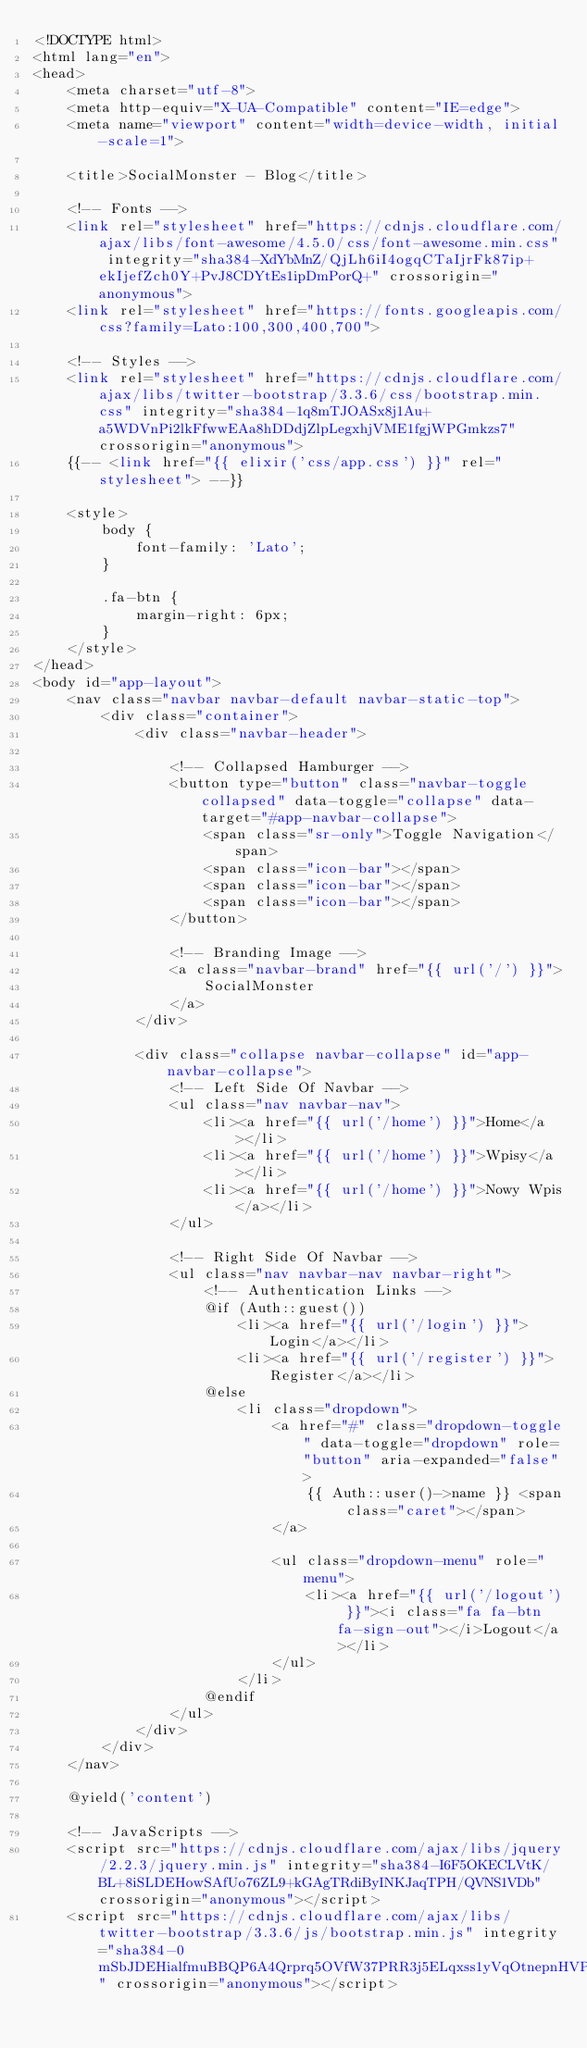Convert code to text. <code><loc_0><loc_0><loc_500><loc_500><_PHP_><!DOCTYPE html>
<html lang="en">
<head>
    <meta charset="utf-8">
    <meta http-equiv="X-UA-Compatible" content="IE=edge">
    <meta name="viewport" content="width=device-width, initial-scale=1">

    <title>SocialMonster - Blog</title>

    <!-- Fonts -->
    <link rel="stylesheet" href="https://cdnjs.cloudflare.com/ajax/libs/font-awesome/4.5.0/css/font-awesome.min.css" integrity="sha384-XdYbMnZ/QjLh6iI4ogqCTaIjrFk87ip+ekIjefZch0Y+PvJ8CDYtEs1ipDmPorQ+" crossorigin="anonymous">
    <link rel="stylesheet" href="https://fonts.googleapis.com/css?family=Lato:100,300,400,700">

    <!-- Styles -->
    <link rel="stylesheet" href="https://cdnjs.cloudflare.com/ajax/libs/twitter-bootstrap/3.3.6/css/bootstrap.min.css" integrity="sha384-1q8mTJOASx8j1Au+a5WDVnPi2lkFfwwEAa8hDDdjZlpLegxhjVME1fgjWPGmkzs7" crossorigin="anonymous">
    {{-- <link href="{{ elixir('css/app.css') }}" rel="stylesheet"> --}}

    <style>
        body {
            font-family: 'Lato';
        }

        .fa-btn {
            margin-right: 6px;
        }
    </style>
</head>
<body id="app-layout">
    <nav class="navbar navbar-default navbar-static-top">
        <div class="container">
            <div class="navbar-header">

                <!-- Collapsed Hamburger -->
                <button type="button" class="navbar-toggle collapsed" data-toggle="collapse" data-target="#app-navbar-collapse">
                    <span class="sr-only">Toggle Navigation</span>
                    <span class="icon-bar"></span>
                    <span class="icon-bar"></span>
                    <span class="icon-bar"></span>
                </button>

                <!-- Branding Image -->
                <a class="navbar-brand" href="{{ url('/') }}">
                    SocialMonster
                </a>
            </div>

            <div class="collapse navbar-collapse" id="app-navbar-collapse">
                <!-- Left Side Of Navbar -->
                <ul class="nav navbar-nav">
                    <li><a href="{{ url('/home') }}">Home</a></li>
                    <li><a href="{{ url('/home') }}">Wpisy</a></li>
                    <li><a href="{{ url('/home') }}">Nowy Wpis</a></li>
                </ul>

                <!-- Right Side Of Navbar -->
                <ul class="nav navbar-nav navbar-right">
                    <!-- Authentication Links -->
                    @if (Auth::guest())
                        <li><a href="{{ url('/login') }}">Login</a></li>
                        <li><a href="{{ url('/register') }}">Register</a></li>
                    @else
                        <li class="dropdown">
                            <a href="#" class="dropdown-toggle" data-toggle="dropdown" role="button" aria-expanded="false">
                                {{ Auth::user()->name }} <span class="caret"></span>
                            </a>

                            <ul class="dropdown-menu" role="menu">
                                <li><a href="{{ url('/logout') }}"><i class="fa fa-btn fa-sign-out"></i>Logout</a></li>
                            </ul>
                        </li>
                    @endif
                </ul>
            </div>
        </div>
    </nav>

    @yield('content')

    <!-- JavaScripts -->
    <script src="https://cdnjs.cloudflare.com/ajax/libs/jquery/2.2.3/jquery.min.js" integrity="sha384-I6F5OKECLVtK/BL+8iSLDEHowSAfUo76ZL9+kGAgTRdiByINKJaqTPH/QVNS1VDb" crossorigin="anonymous"></script>
    <script src="https://cdnjs.cloudflare.com/ajax/libs/twitter-bootstrap/3.3.6/js/bootstrap.min.js" integrity="sha384-0mSbJDEHialfmuBBQP6A4Qrprq5OVfW37PRR3j5ELqxss1yVqOtnepnHVP9aJ7xS" crossorigin="anonymous"></script></code> 